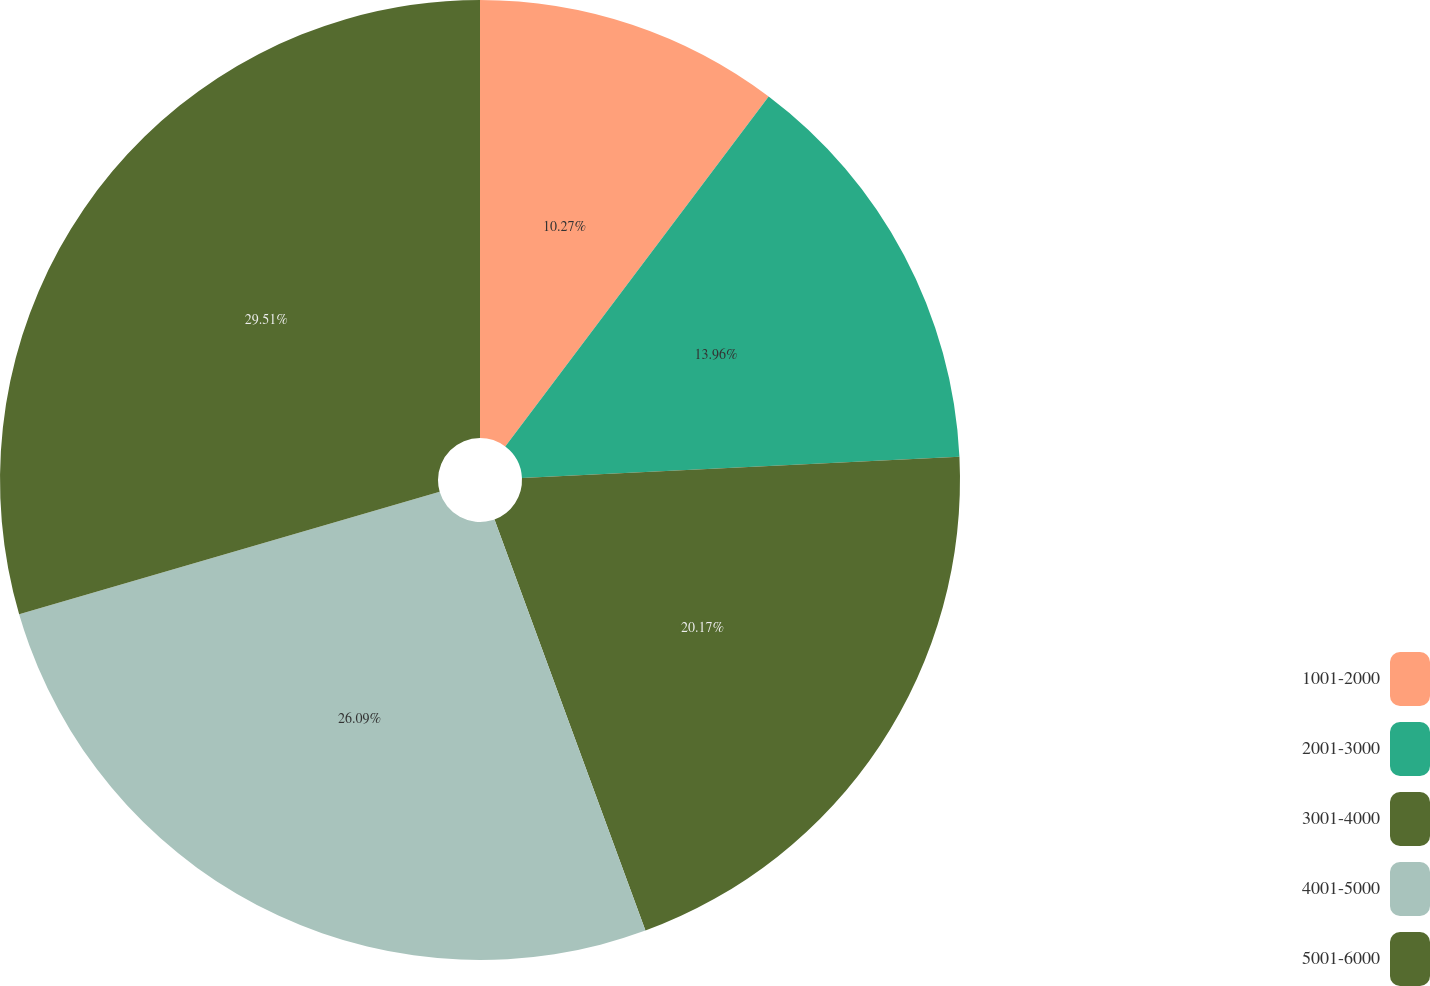<chart> <loc_0><loc_0><loc_500><loc_500><pie_chart><fcel>1001-2000<fcel>2001-3000<fcel>3001-4000<fcel>4001-5000<fcel>5001-6000<nl><fcel>10.27%<fcel>13.96%<fcel>20.17%<fcel>26.09%<fcel>29.51%<nl></chart> 